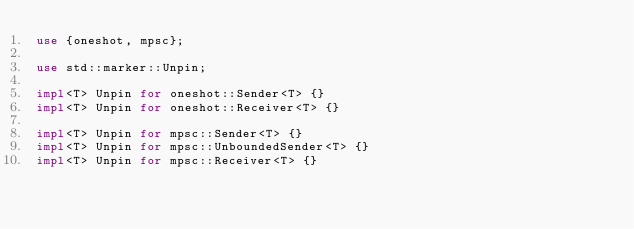Convert code to text. <code><loc_0><loc_0><loc_500><loc_500><_Rust_>use {oneshot, mpsc};

use std::marker::Unpin;

impl<T> Unpin for oneshot::Sender<T> {}
impl<T> Unpin for oneshot::Receiver<T> {}

impl<T> Unpin for mpsc::Sender<T> {}
impl<T> Unpin for mpsc::UnboundedSender<T> {}
impl<T> Unpin for mpsc::Receiver<T> {}
</code> 